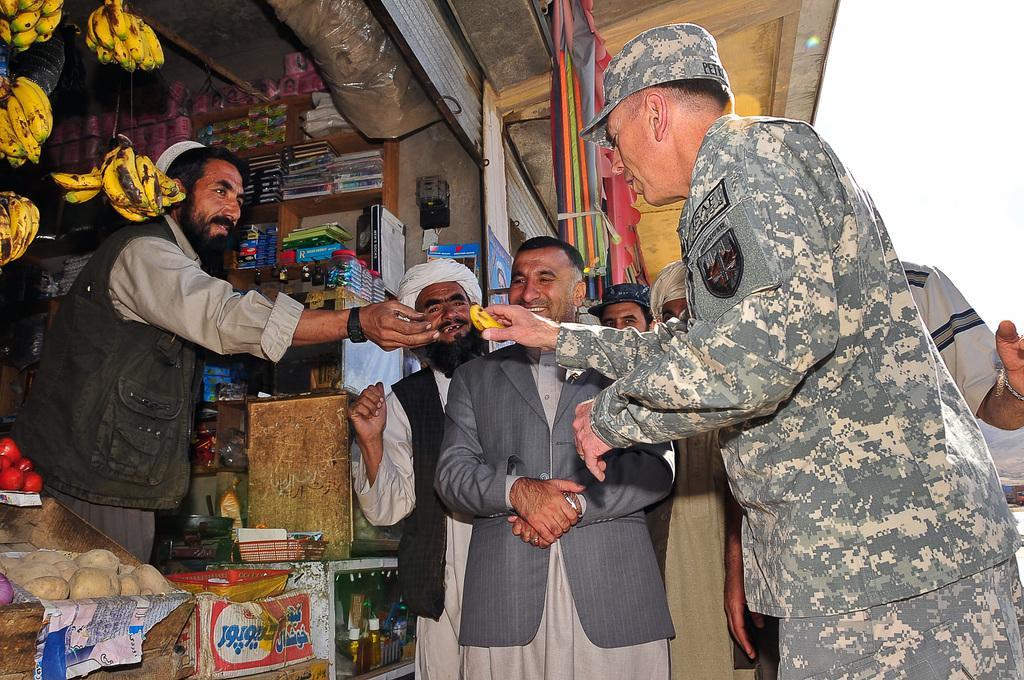Can you describe this image briefly? In the picture we can see a shop with a shopkeeper and in the shop we can see some bananas are hung to the roof and some things on the desk and in the racks we can see some books and something placed in it and outside the shop we can see some people standing and one man is wearing an army uniform and buying something. 